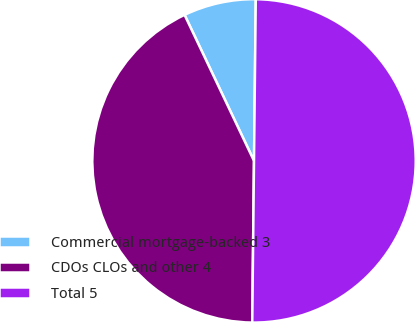<chart> <loc_0><loc_0><loc_500><loc_500><pie_chart><fcel>Commercial mortgage-backed 3<fcel>CDOs CLOs and other 4<fcel>Total 5<nl><fcel>7.24%<fcel>42.76%<fcel>50.0%<nl></chart> 